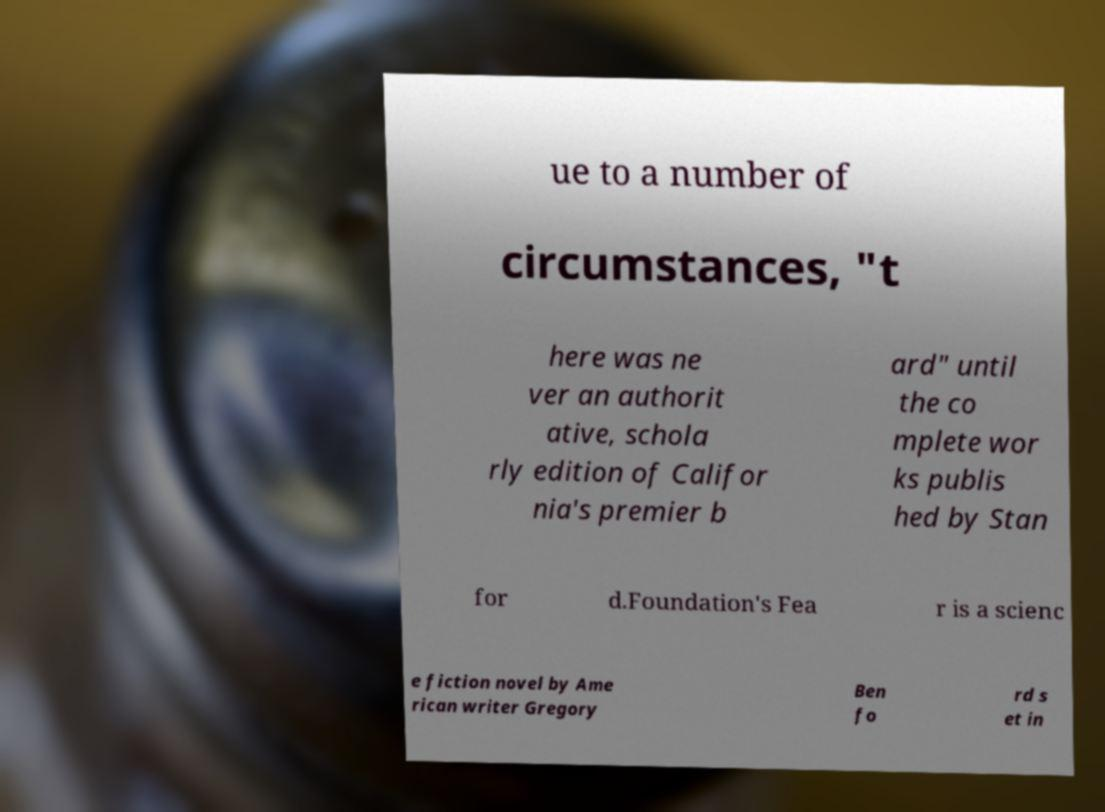I need the written content from this picture converted into text. Can you do that? ue to a number of circumstances, "t here was ne ver an authorit ative, schola rly edition of Califor nia's premier b ard" until the co mplete wor ks publis hed by Stan for d.Foundation's Fea r is a scienc e fiction novel by Ame rican writer Gregory Ben fo rd s et in 